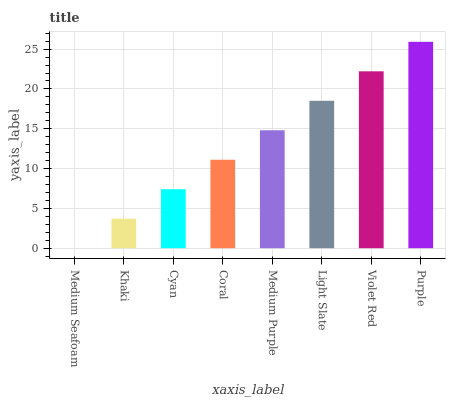Is Medium Seafoam the minimum?
Answer yes or no. Yes. Is Purple the maximum?
Answer yes or no. Yes. Is Khaki the minimum?
Answer yes or no. No. Is Khaki the maximum?
Answer yes or no. No. Is Khaki greater than Medium Seafoam?
Answer yes or no. Yes. Is Medium Seafoam less than Khaki?
Answer yes or no. Yes. Is Medium Seafoam greater than Khaki?
Answer yes or no. No. Is Khaki less than Medium Seafoam?
Answer yes or no. No. Is Medium Purple the high median?
Answer yes or no. Yes. Is Coral the low median?
Answer yes or no. Yes. Is Coral the high median?
Answer yes or no. No. Is Khaki the low median?
Answer yes or no. No. 